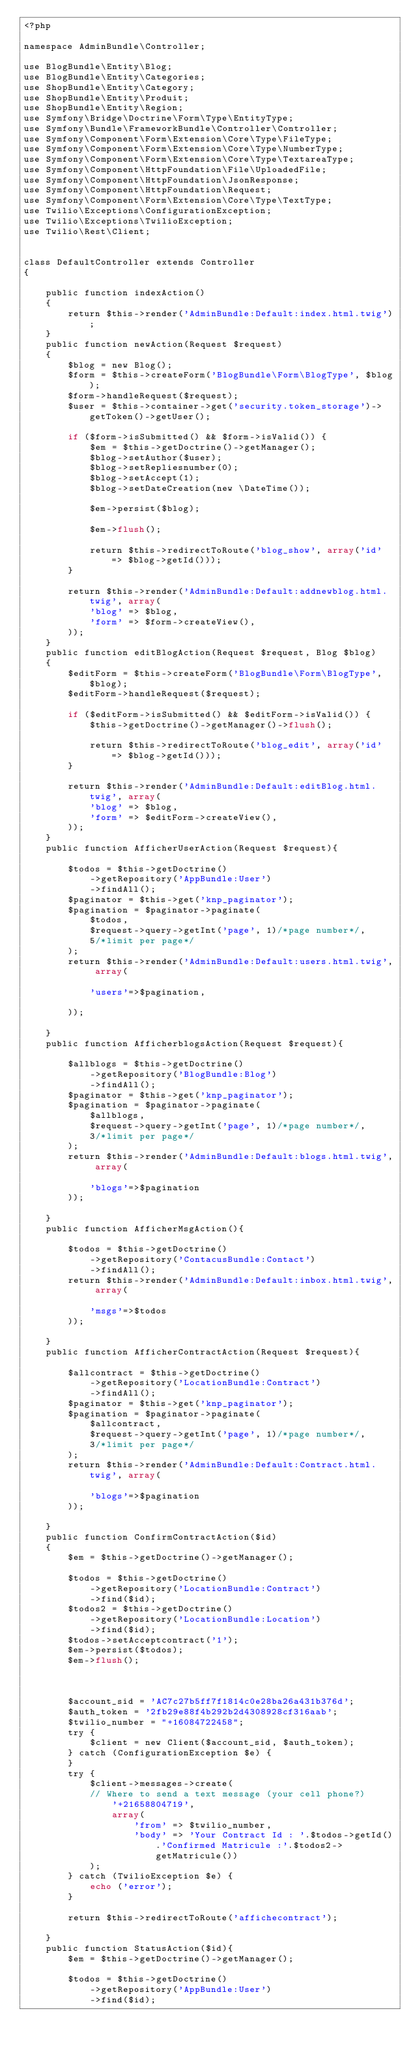<code> <loc_0><loc_0><loc_500><loc_500><_PHP_><?php

namespace AdminBundle\Controller;

use BlogBundle\Entity\Blog;
use BlogBundle\Entity\Categories;
use ShopBundle\Entity\Category;
use ShopBundle\Entity\Produit;
use ShopBundle\Entity\Region;
use Symfony\Bridge\Doctrine\Form\Type\EntityType;
use Symfony\Bundle\FrameworkBundle\Controller\Controller;
use Symfony\Component\Form\Extension\Core\Type\FileType;
use Symfony\Component\Form\Extension\Core\Type\NumberType;
use Symfony\Component\Form\Extension\Core\Type\TextareaType;
use Symfony\Component\HttpFoundation\File\UploadedFile;
use Symfony\Component\HttpFoundation\JsonResponse;
use Symfony\Component\HttpFoundation\Request;
use Symfony\Component\Form\Extension\Core\Type\TextType;
use Twilio\Exceptions\ConfigurationException;
use Twilio\Exceptions\TwilioException;
use Twilio\Rest\Client;


class DefaultController extends Controller
{

    public function indexAction()
    {
        return $this->render('AdminBundle:Default:index.html.twig');
    }
    public function newAction(Request $request)
    {
        $blog = new Blog();
        $form = $this->createForm('BlogBundle\Form\BlogType', $blog);
        $form->handleRequest($request);
        $user = $this->container->get('security.token_storage')->getToken()->getUser();

        if ($form->isSubmitted() && $form->isValid()) {
            $em = $this->getDoctrine()->getManager();
            $blog->setAuthor($user);
            $blog->setRepliesnumber(0);
            $blog->setAccept(1);
            $blog->setDateCreation(new \DateTime());

            $em->persist($blog);

            $em->flush();

            return $this->redirectToRoute('blog_show', array('id' => $blog->getId()));
        }

        return $this->render('AdminBundle:Default:addnewblog.html.twig', array(
            'blog' => $blog,
            'form' => $form->createView(),
        ));
    }
    public function editBlogAction(Request $request, Blog $blog)
    {
        $editForm = $this->createForm('BlogBundle\Form\BlogType', $blog);
        $editForm->handleRequest($request);

        if ($editForm->isSubmitted() && $editForm->isValid()) {
            $this->getDoctrine()->getManager()->flush();

            return $this->redirectToRoute('blog_edit', array('id' => $blog->getId()));
        }

        return $this->render('AdminBundle:Default:editBlog.html.twig', array(
            'blog' => $blog,
            'form' => $editForm->createView(),
        ));
    }
    public function AfficherUserAction(Request $request){

        $todos = $this->getDoctrine()
            ->getRepository('AppBundle:User')
            ->findAll();
        $paginator = $this->get('knp_paginator');
        $pagination = $paginator->paginate(
            $todos,
            $request->query->getInt('page', 1)/*page number*/,
            5/*limit per page*/
        );
        return $this->render('AdminBundle:Default:users.html.twig', array(

            'users'=>$pagination,

        ));

    }
    public function AfficherblogsAction(Request $request){

        $allblogs = $this->getDoctrine()
            ->getRepository('BlogBundle:Blog')
            ->findAll();
        $paginator = $this->get('knp_paginator');
        $pagination = $paginator->paginate(
            $allblogs,
            $request->query->getInt('page', 1)/*page number*/,
            3/*limit per page*/
        );
        return $this->render('AdminBundle:Default:blogs.html.twig', array(

            'blogs'=>$pagination
        ));

    }
    public function AfficherMsgAction(){

        $todos = $this->getDoctrine()
            ->getRepository('ContacusBundle:Contact')
            ->findAll();
        return $this->render('AdminBundle:Default:inbox.html.twig', array(

            'msgs'=>$todos
        ));

    }
    public function AfficherContractAction(Request $request){

        $allcontract = $this->getDoctrine()
            ->getRepository('LocationBundle:Contract')
            ->findAll();
        $paginator = $this->get('knp_paginator');
        $pagination = $paginator->paginate(
            $allcontract,
            $request->query->getInt('page', 1)/*page number*/,
            3/*limit per page*/
        );
        return $this->render('AdminBundle:Default:Contract.html.twig', array(

            'blogs'=>$pagination
        ));

    }
    public function ConfirmContractAction($id)
    {
        $em = $this->getDoctrine()->getManager();

        $todos = $this->getDoctrine()
            ->getRepository('LocationBundle:Contract')
            ->find($id);
        $todos2 = $this->getDoctrine()
            ->getRepository('LocationBundle:Location')
            ->find($id);
        $todos->setAcceptcontract('1');
        $em->persist($todos);
        $em->flush();



        $account_sid = 'AC7c27b5ff7f1814c0e28ba26a431b376d';
        $auth_token = '2fb29e88f4b292b2d4308928cf316aab';
        $twilio_number = "+16084722458";
        try {
            $client = new Client($account_sid, $auth_token);
        } catch (ConfigurationException $e) {
        }
        try {
            $client->messages->create(
            // Where to send a text message (your cell phone?)
                '+21658804719',
                array(
                    'from' => $twilio_number,
                    'body' => 'Your Contract Id : '.$todos->getId().'Confirmed Matricule :'.$todos2->getMatricule())
            );
        } catch (TwilioException $e) {
            echo ('error');
        }

        return $this->redirectToRoute('affichecontract');

    }
    public function StatusAction($id){
        $em = $this->getDoctrine()->getManager();

        $todos = $this->getDoctrine()
            ->getRepository('AppBundle:User')
            ->find($id);
</code> 